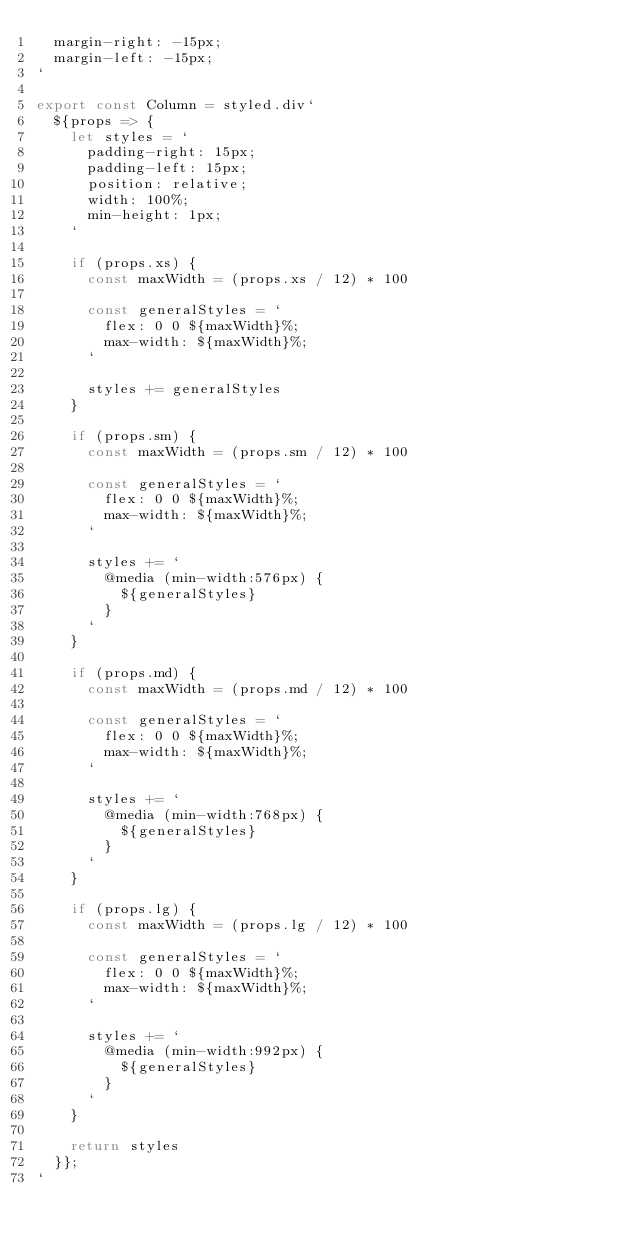<code> <loc_0><loc_0><loc_500><loc_500><_JavaScript_>  margin-right: -15px;
  margin-left: -15px;
`

export const Column = styled.div`
  ${props => {
    let styles = `
      padding-right: 15px;
      padding-left: 15px;
      position: relative;
      width: 100%;
      min-height: 1px;
    `

    if (props.xs) {
      const maxWidth = (props.xs / 12) * 100

      const generalStyles = `
        flex: 0 0 ${maxWidth}%;
        max-width: ${maxWidth}%;
      `

      styles += generalStyles
    }

    if (props.sm) {
      const maxWidth = (props.sm / 12) * 100

      const generalStyles = `
        flex: 0 0 ${maxWidth}%;
        max-width: ${maxWidth}%;
      `

      styles += `
        @media (min-width:576px) {
          ${generalStyles}
        }
      `
    }

    if (props.md) {
      const maxWidth = (props.md / 12) * 100

      const generalStyles = `
        flex: 0 0 ${maxWidth}%;
        max-width: ${maxWidth}%;
      `

      styles += `
        @media (min-width:768px) {
          ${generalStyles}
        }
      `
    }

    if (props.lg) {
      const maxWidth = (props.lg / 12) * 100

      const generalStyles = `
        flex: 0 0 ${maxWidth}%;
        max-width: ${maxWidth}%;
      `

      styles += `
        @media (min-width:992px) {
          ${generalStyles}
        }
      `
    }

    return styles
  }};
`
</code> 